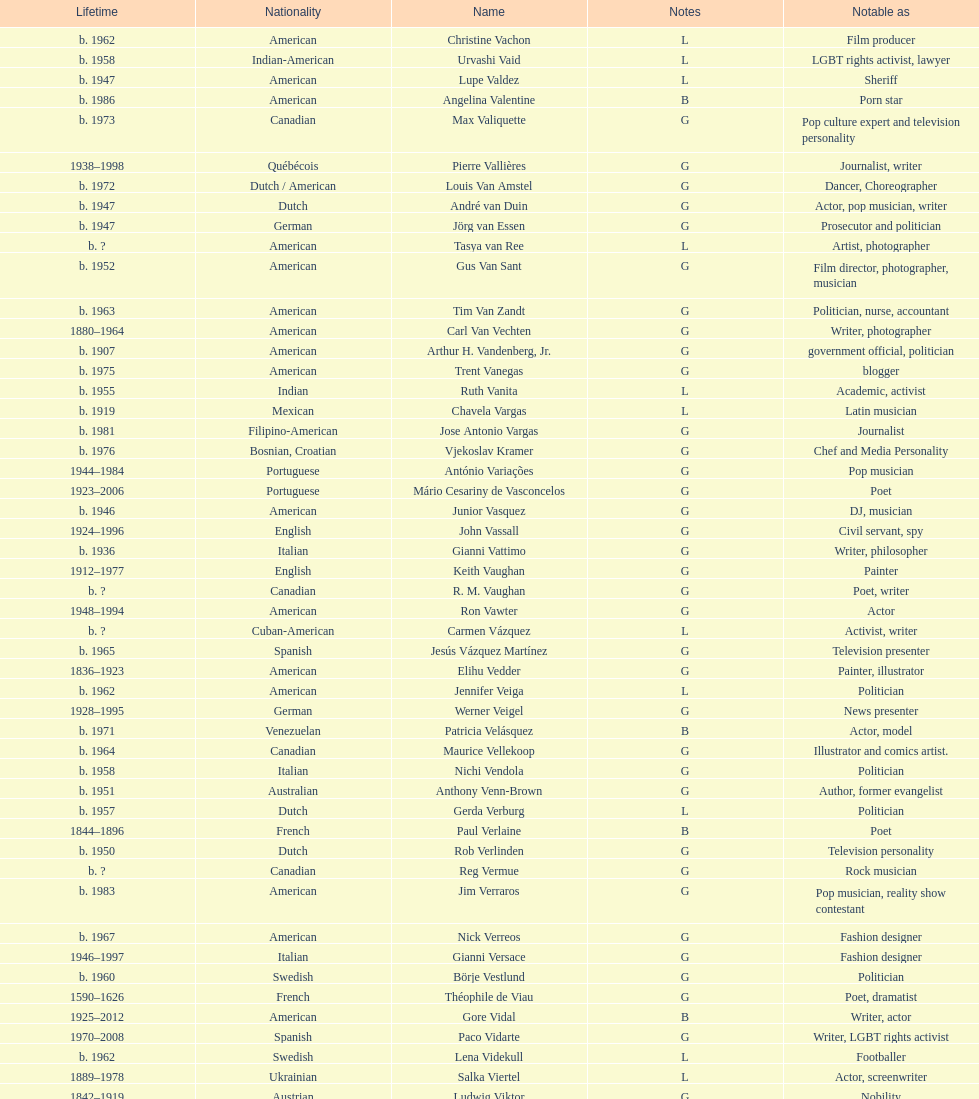Can you parse all the data within this table? {'header': ['Lifetime', 'Nationality', 'Name', 'Notes', 'Notable as'], 'rows': [['b. 1962', 'American', 'Christine Vachon', 'L', 'Film producer'], ['b. 1958', 'Indian-American', 'Urvashi Vaid', 'L', 'LGBT rights activist, lawyer'], ['b. 1947', 'American', 'Lupe Valdez', 'L', 'Sheriff'], ['b. 1986', 'American', 'Angelina Valentine', 'B', 'Porn star'], ['b. 1973', 'Canadian', 'Max Valiquette', 'G', 'Pop culture expert and television personality'], ['1938–1998', 'Québécois', 'Pierre Vallières', 'G', 'Journalist, writer'], ['b. 1972', 'Dutch / American', 'Louis Van Amstel', 'G', 'Dancer, Choreographer'], ['b. 1947', 'Dutch', 'André van Duin', 'G', 'Actor, pop musician, writer'], ['b. 1947', 'German', 'Jörg van Essen', 'G', 'Prosecutor and politician'], ['b.\xa0?', 'American', 'Tasya van Ree', 'L', 'Artist, photographer'], ['b. 1952', 'American', 'Gus Van Sant', 'G', 'Film director, photographer, musician'], ['b. 1963', 'American', 'Tim Van Zandt', 'G', 'Politician, nurse, accountant'], ['1880–1964', 'American', 'Carl Van Vechten', 'G', 'Writer, photographer'], ['b. 1907', 'American', 'Arthur H. Vandenberg, Jr.', 'G', 'government official, politician'], ['b. 1975', 'American', 'Trent Vanegas', 'G', 'blogger'], ['b. 1955', 'Indian', 'Ruth Vanita', 'L', 'Academic, activist'], ['b. 1919', 'Mexican', 'Chavela Vargas', 'L', 'Latin musician'], ['b. 1981', 'Filipino-American', 'Jose Antonio Vargas', 'G', 'Journalist'], ['b. 1976', 'Bosnian, Croatian', 'Vjekoslav Kramer', 'G', 'Chef and Media Personality'], ['1944–1984', 'Portuguese', 'António Variações', 'G', 'Pop musician'], ['1923–2006', 'Portuguese', 'Mário Cesariny de Vasconcelos', 'G', 'Poet'], ['b. 1946', 'American', 'Junior Vasquez', 'G', 'DJ, musician'], ['1924–1996', 'English', 'John Vassall', 'G', 'Civil servant, spy'], ['b. 1936', 'Italian', 'Gianni Vattimo', 'G', 'Writer, philosopher'], ['1912–1977', 'English', 'Keith Vaughan', 'G', 'Painter'], ['b.\xa0?', 'Canadian', 'R. M. Vaughan', 'G', 'Poet, writer'], ['1948–1994', 'American', 'Ron Vawter', 'G', 'Actor'], ['b.\xa0?', 'Cuban-American', 'Carmen Vázquez', 'L', 'Activist, writer'], ['b. 1965', 'Spanish', 'Jesús Vázquez Martínez', 'G', 'Television presenter'], ['1836–1923', 'American', 'Elihu Vedder', 'G', 'Painter, illustrator'], ['b. 1962', 'American', 'Jennifer Veiga', 'L', 'Politician'], ['1928–1995', 'German', 'Werner Veigel', 'G', 'News presenter'], ['b. 1971', 'Venezuelan', 'Patricia Velásquez', 'B', 'Actor, model'], ['b. 1964', 'Canadian', 'Maurice Vellekoop', 'G', 'Illustrator and comics artist.'], ['b. 1958', 'Italian', 'Nichi Vendola', 'G', 'Politician'], ['b. 1951', 'Australian', 'Anthony Venn-Brown', 'G', 'Author, former evangelist'], ['b. 1957', 'Dutch', 'Gerda Verburg', 'L', 'Politician'], ['1844–1896', 'French', 'Paul Verlaine', 'B', 'Poet'], ['b. 1950', 'Dutch', 'Rob Verlinden', 'G', 'Television personality'], ['b.\xa0?', 'Canadian', 'Reg Vermue', 'G', 'Rock musician'], ['b. 1983', 'American', 'Jim Verraros', 'G', 'Pop musician, reality show contestant'], ['b. 1967', 'American', 'Nick Verreos', 'G', 'Fashion designer'], ['1946–1997', 'Italian', 'Gianni Versace', 'G', 'Fashion designer'], ['b. 1960', 'Swedish', 'Börje Vestlund', 'G', 'Politician'], ['1590–1626', 'French', 'Théophile de Viau', 'G', 'Poet, dramatist'], ['1925–2012', 'American', 'Gore Vidal', 'B', 'Writer, actor'], ['1970–2008', 'Spanish', 'Paco Vidarte', 'G', 'Writer, LGBT rights activist'], ['b. 1962', 'Swedish', 'Lena Videkull', 'L', 'Footballer'], ['1889–1978', 'Ukrainian', 'Salka Viertel', 'L', 'Actor, screenwriter'], ['1842–1919', 'Austrian', 'Ludwig Viktor', 'G', 'Nobility'], ['b. 1948', 'American', 'Bruce Vilanch', 'G', 'Comedy writer, actor'], ['1953–1994', 'American', 'Tom Villard', 'G', 'Actor'], ['b. 1961', 'American', 'José Villarrubia', 'G', 'Artist'], ['1903–1950', 'Mexican', 'Xavier Villaurrutia', 'G', 'Poet, playwright'], ['1950–2000', 'French', "Alain-Philippe Malagnac d'Argens de Villèle", 'G', 'Aristocrat'], ['b.\xa0?', 'American', 'Norah Vincent', 'L', 'Journalist'], ['1917–1998', 'American', 'Donald Vining', 'G', 'Writer'], ['1906–1976', 'Italian', 'Luchino Visconti', 'G', 'Filmmaker'], ['b. 1962', 'Czech', 'Pavel Vítek', 'G', 'Pop musician, actor'], ['1877–1909', 'English', 'Renée Vivien', 'L', 'Poet'], ['1948–1983', 'Canadian', 'Claude Vivier', 'G', '20th century classical composer'], ['b. 1983', 'American', 'Taylor Vixen', 'B', 'Porn star'], ['1934–1994', 'American', 'Bruce Voeller', 'G', 'HIV/AIDS researcher'], ['b. 1951', 'American', 'Paula Vogel', 'L', 'Playwright'], ['b. 1985', 'Russian', 'Julia Volkova', 'B', 'Singer'], ['b. 1947', 'German', 'Jörg van Essen', 'G', 'Politician'], ['b. 1955', 'German', 'Ole von Beust', 'G', 'Politician'], ['1856–1931', 'German', 'Wilhelm von Gloeden', 'G', 'Photographer'], ['b. 1942', 'German', 'Rosa von Praunheim', 'G', 'Film director'], ['b. 1901–1996', 'German', 'Kurt von Ruffin', 'G', 'Holocaust survivor'], ['b. 1959', 'German', 'Hella von Sinnen', 'L', 'Comedian'], ['b. 1981', 'American', 'Daniel Vosovic', 'G', 'Fashion designer'], ['b. 1966', 'Canadian', 'Delwin Vriend', 'G', 'LGBT rights activist']]} How old was pierre vallieres before he died? 60. 